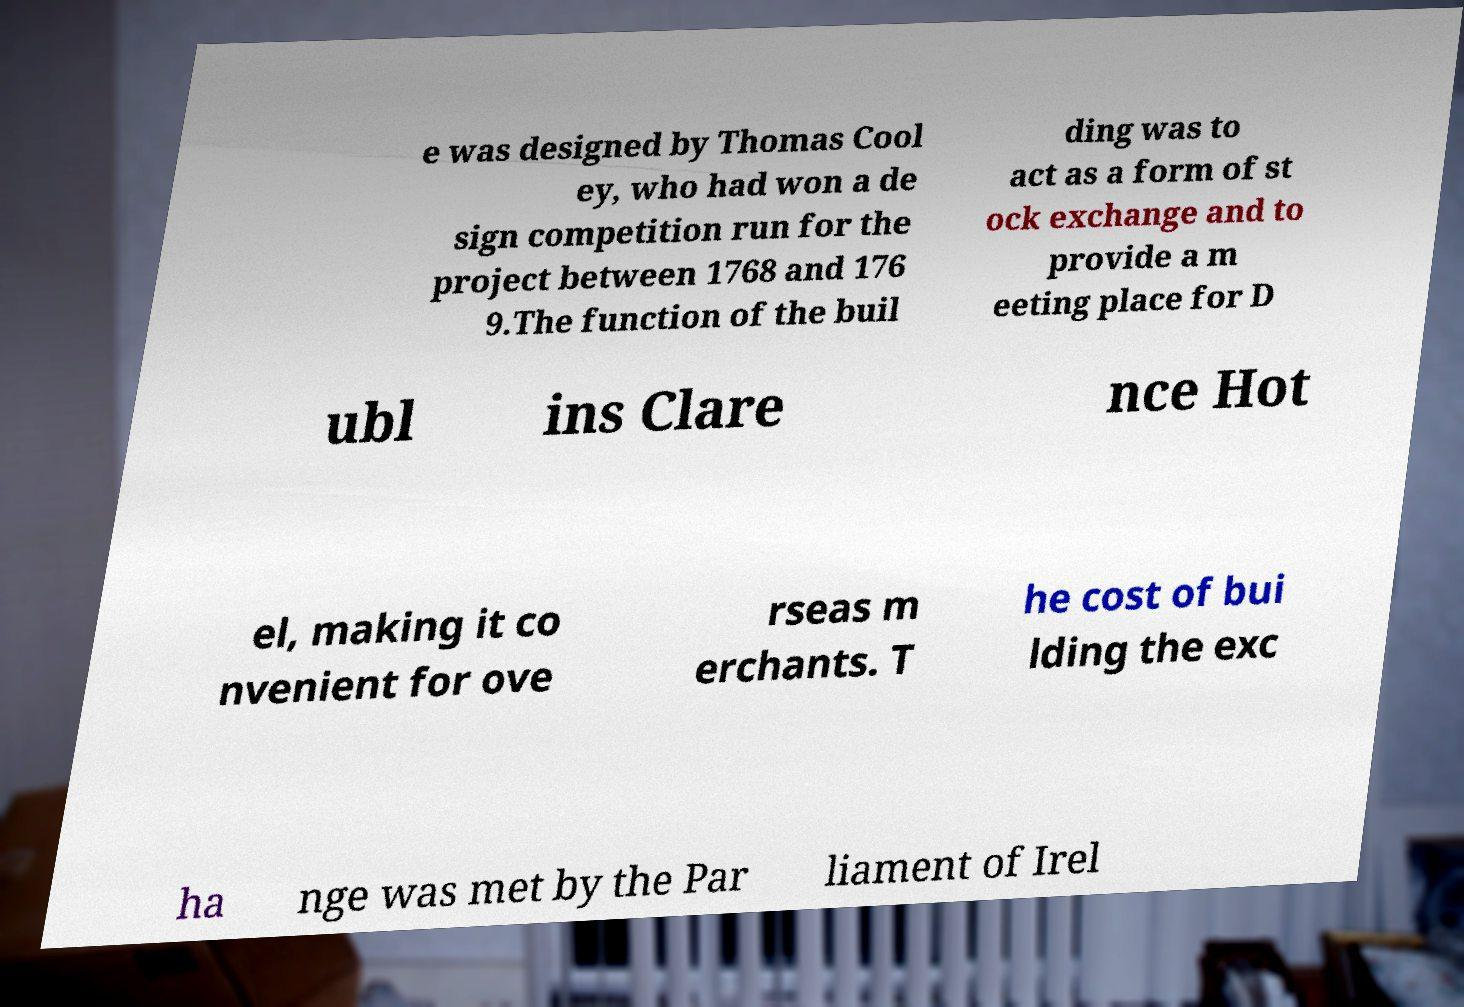Can you accurately transcribe the text from the provided image for me? e was designed by Thomas Cool ey, who had won a de sign competition run for the project between 1768 and 176 9.The function of the buil ding was to act as a form of st ock exchange and to provide a m eeting place for D ubl ins Clare nce Hot el, making it co nvenient for ove rseas m erchants. T he cost of bui lding the exc ha nge was met by the Par liament of Irel 